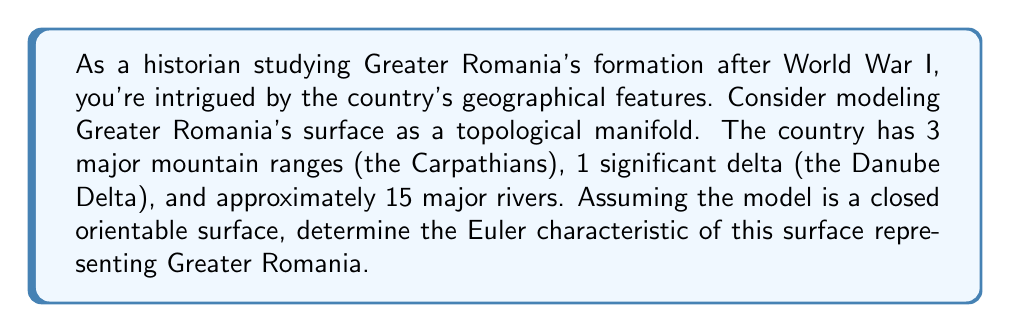Could you help me with this problem? To solve this problem, we need to use the concept of the Euler characteristic for a closed orientable surface. The Euler characteristic $\chi$ is given by the formula:

$$\chi = V - E + F$$

Where:
$V$ = number of vertices
$E$ = number of edges
$F$ = number of faces

For our model of Greater Romania:

1. Mountain ranges can be considered as vertices: $V = 3$

2. Major rivers can be considered as edges: $E = 15$

3. To find the number of faces, we can use the Euler-Poincaré formula for a closed orientable surface:

   $$\chi = 2 - 2g$$

   Where $g$ is the genus (number of "holes" or "handles") of the surface.

4. The Danube Delta can be considered as a handle, so $g = 1$

5. Substituting into the Euler-Poincaré formula:

   $$\chi = 2 - 2(1) = 0$$

6. Now we can find $F$ using the original Euler characteristic formula:

   $$0 = 3 - 15 + F$$
   $$F = 12$$

Therefore, our model of Greater Romania has 3 vertices, 15 edges, and 12 faces.
Answer: The Euler characteristic of the surface modeling Greater Romania's geographical features is $\chi = 0$. 